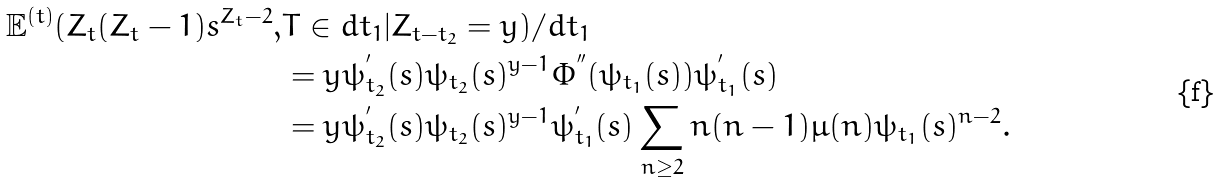<formula> <loc_0><loc_0><loc_500><loc_500>\mathbb { E } ^ { ( t ) } ( Z _ { t } ( Z _ { t } - 1 ) s ^ { Z _ { t } - 2 } , & T \in d t _ { 1 } | Z _ { t - t _ { 2 } } = y ) / d t _ { 1 } \\ & = y \psi _ { t _ { 2 } } ^ { ^ { \prime } } ( s ) \psi _ { t _ { 2 } } ( s ) ^ { y - 1 } \Phi ^ { ^ { \prime \prime } } ( \psi _ { t _ { 1 } } ( s ) ) \psi _ { t _ { 1 } } ^ { ^ { \prime } } ( s ) \\ & = y \psi _ { t _ { 2 } } ^ { ^ { \prime } } ( s ) \psi _ { t _ { 2 } } ( s ) ^ { y - 1 } \psi _ { t _ { 1 } } ^ { ^ { \prime } } ( s ) \sum _ { n \geq 2 } n ( n - 1 ) \mu ( n ) \psi _ { t _ { 1 } } ( s ) ^ { n - 2 } .</formula> 